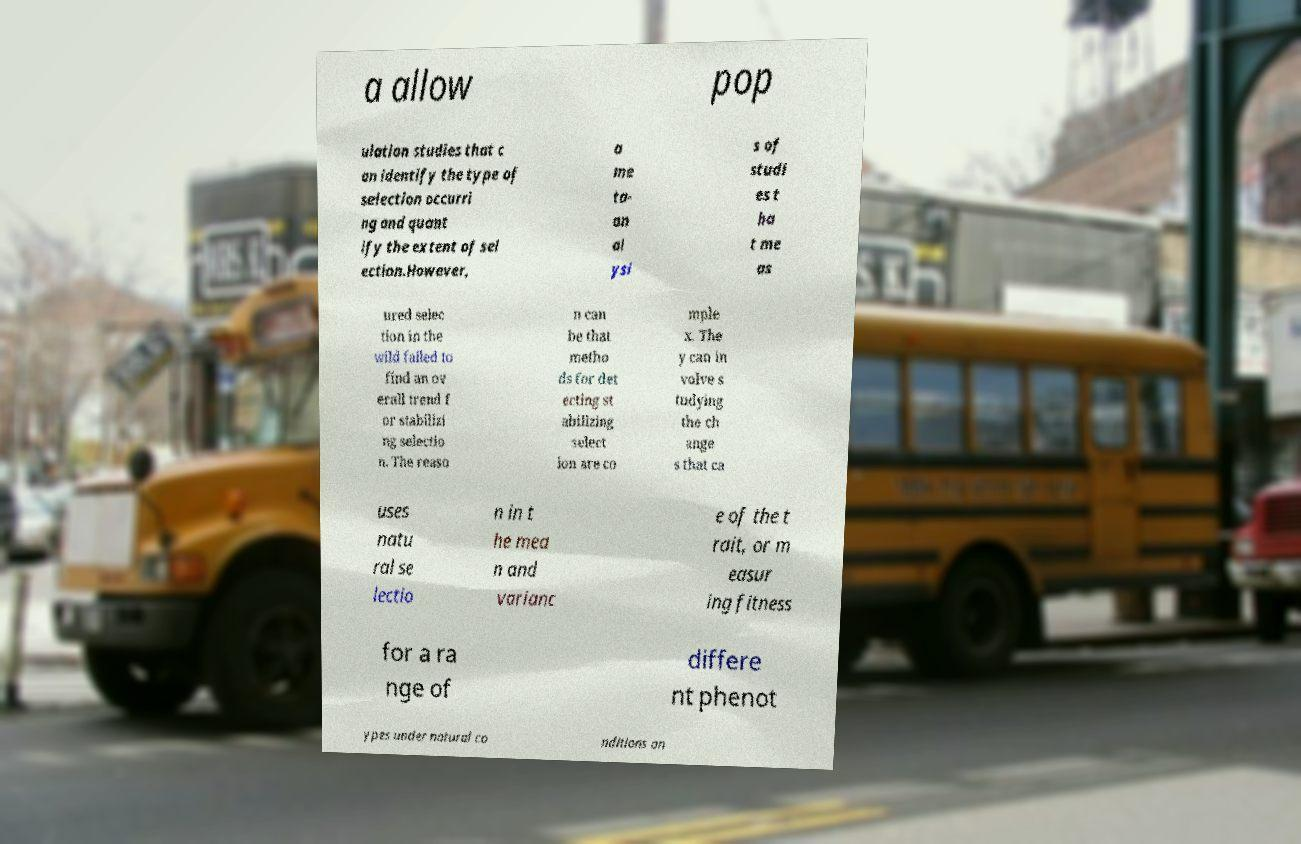There's text embedded in this image that I need extracted. Can you transcribe it verbatim? a allow pop ulation studies that c an identify the type of selection occurri ng and quant ify the extent of sel ection.However, a me ta- an al ysi s of studi es t ha t me as ured selec tion in the wild failed to find an ov erall trend f or stabilizi ng selectio n. The reaso n can be that metho ds for det ecting st abilizing select ion are co mple x. The y can in volve s tudying the ch ange s that ca uses natu ral se lectio n in t he mea n and varianc e of the t rait, or m easur ing fitness for a ra nge of differe nt phenot ypes under natural co nditions an 